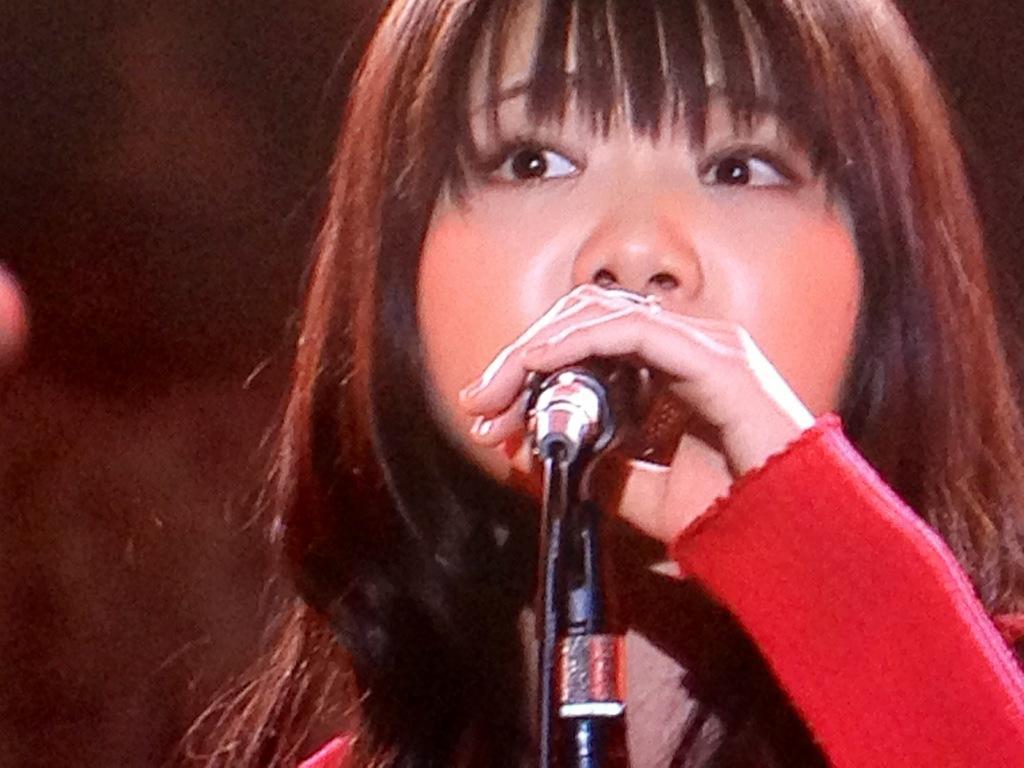Describe this image in one or two sentences. In this picture we can see a girl standing in front of a mike and she is holding a mike in her hand. Hair colour is light brown. Background is dark and blur. 